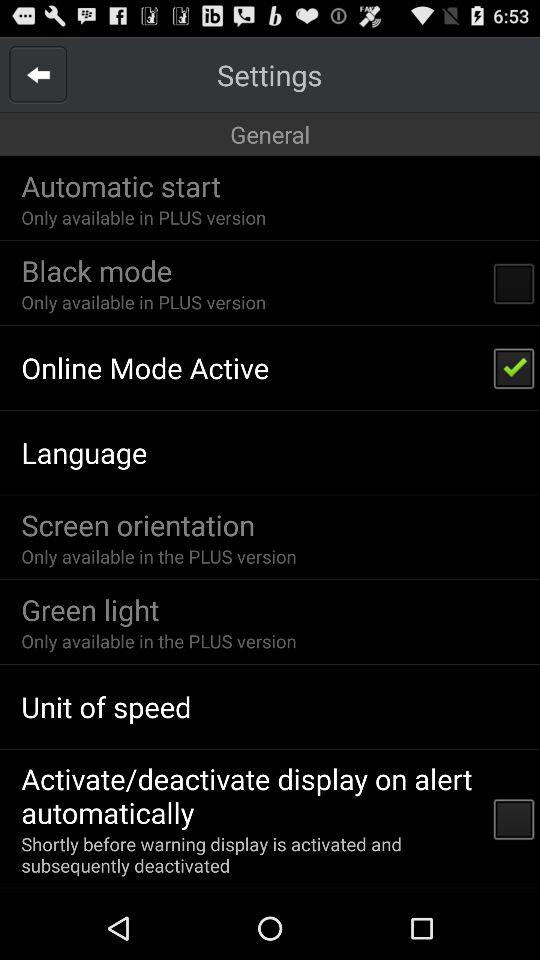What is the status of "Online Mode Active"? The status is "on". 